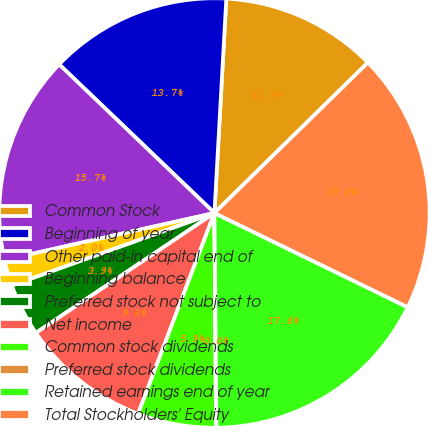Convert chart to OTSL. <chart><loc_0><loc_0><loc_500><loc_500><pie_chart><fcel>Common Stock<fcel>Beginning of year<fcel>Other paid-in capital end of<fcel>Beginning balance<fcel>Preferred stock not subject to<fcel>Net income<fcel>Common stock dividends<fcel>Preferred stock dividends<fcel>Retained earnings end of year<fcel>Total Stockholders' Equity<nl><fcel>11.76%<fcel>13.71%<fcel>15.67%<fcel>1.98%<fcel>3.94%<fcel>9.8%<fcel>5.89%<fcel>0.03%<fcel>17.62%<fcel>19.58%<nl></chart> 